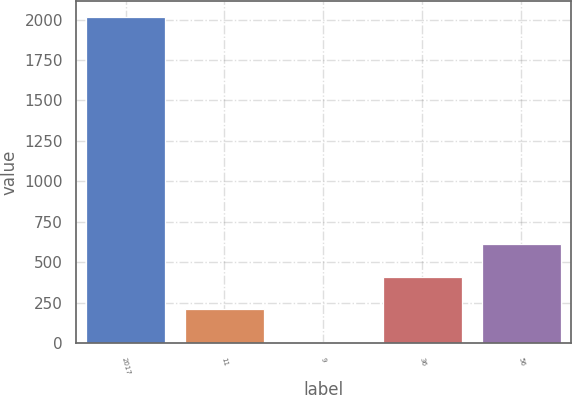Convert chart. <chart><loc_0><loc_0><loc_500><loc_500><bar_chart><fcel>2017<fcel>11<fcel>9<fcel>36<fcel>56<nl><fcel>2016<fcel>208.8<fcel>8<fcel>409.6<fcel>610.4<nl></chart> 